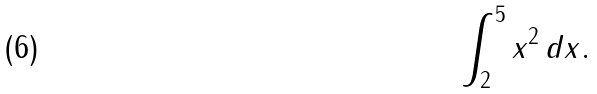Convert formula to latex. <formula><loc_0><loc_0><loc_500><loc_500>\int _ { 2 } ^ { 5 } x ^ { 2 } \, d x .</formula> 